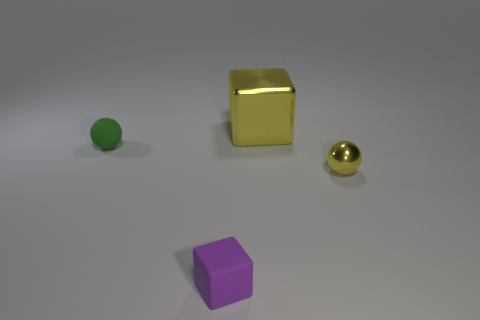How many purple cubes are the same size as the green sphere?
Your answer should be compact. 1. Are there fewer matte spheres that are on the right side of the rubber sphere than small yellow balls in front of the large metallic thing?
Offer a very short reply. Yes. Is there another big red shiny object that has the same shape as the large metallic object?
Give a very brief answer. No. Does the large yellow metallic thing have the same shape as the purple rubber thing?
Your response must be concise. Yes. What number of big objects are yellow balls or green rubber spheres?
Provide a short and direct response. 0. Is the number of big blue matte objects greater than the number of big cubes?
Ensure brevity in your answer.  No. There is a cube that is the same material as the green thing; what is its size?
Your response must be concise. Small. Do the block that is behind the small yellow ball and the ball that is in front of the green rubber object have the same size?
Your response must be concise. No. What number of things are either tiny things on the left side of the metal cube or tiny yellow objects?
Provide a succinct answer. 3. Are there fewer yellow blocks than green blocks?
Your answer should be very brief. No. 